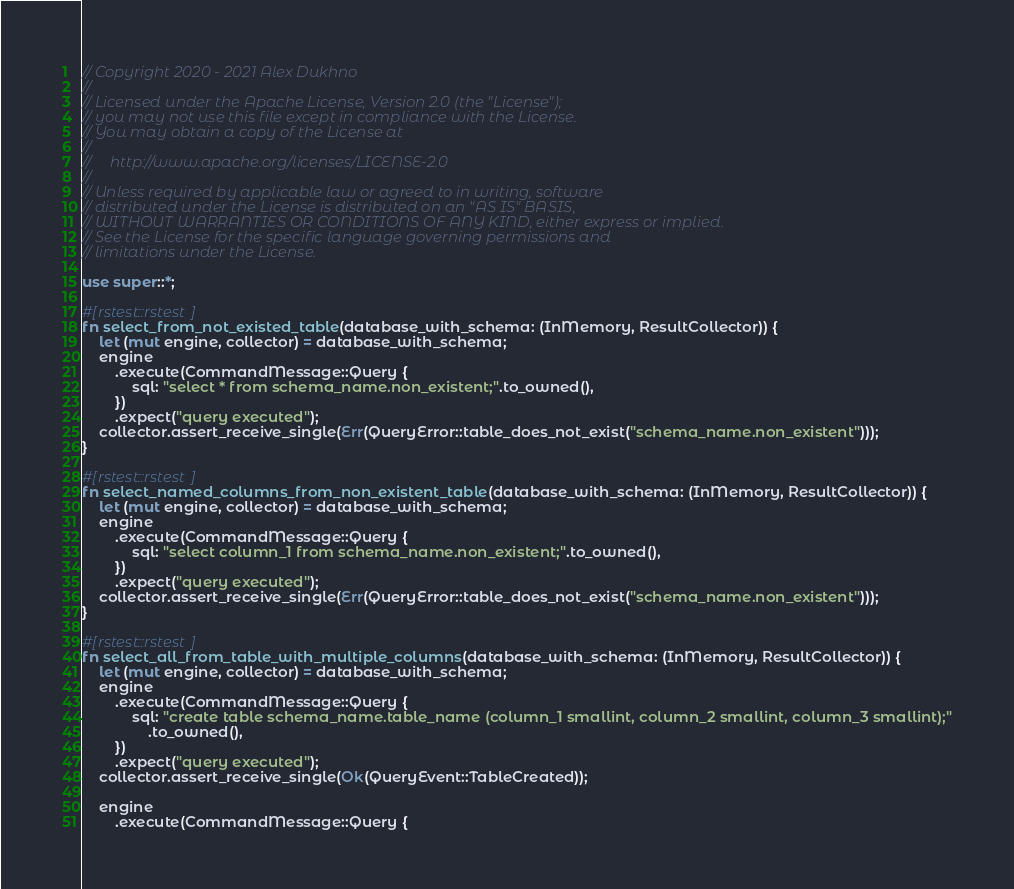<code> <loc_0><loc_0><loc_500><loc_500><_Rust_>// Copyright 2020 - 2021 Alex Dukhno
//
// Licensed under the Apache License, Version 2.0 (the "License");
// you may not use this file except in compliance with the License.
// You may obtain a copy of the License at
//
//     http://www.apache.org/licenses/LICENSE-2.0
//
// Unless required by applicable law or agreed to in writing, software
// distributed under the License is distributed on an "AS IS" BASIS,
// WITHOUT WARRANTIES OR CONDITIONS OF ANY KIND, either express or implied.
// See the License for the specific language governing permissions and
// limitations under the License.

use super::*;

#[rstest::rstest]
fn select_from_not_existed_table(database_with_schema: (InMemory, ResultCollector)) {
    let (mut engine, collector) = database_with_schema;
    engine
        .execute(CommandMessage::Query {
            sql: "select * from schema_name.non_existent;".to_owned(),
        })
        .expect("query executed");
    collector.assert_receive_single(Err(QueryError::table_does_not_exist("schema_name.non_existent")));
}

#[rstest::rstest]
fn select_named_columns_from_non_existent_table(database_with_schema: (InMemory, ResultCollector)) {
    let (mut engine, collector) = database_with_schema;
    engine
        .execute(CommandMessage::Query {
            sql: "select column_1 from schema_name.non_existent;".to_owned(),
        })
        .expect("query executed");
    collector.assert_receive_single(Err(QueryError::table_does_not_exist("schema_name.non_existent")));
}

#[rstest::rstest]
fn select_all_from_table_with_multiple_columns(database_with_schema: (InMemory, ResultCollector)) {
    let (mut engine, collector) = database_with_schema;
    engine
        .execute(CommandMessage::Query {
            sql: "create table schema_name.table_name (column_1 smallint, column_2 smallint, column_3 smallint);"
                .to_owned(),
        })
        .expect("query executed");
    collector.assert_receive_single(Ok(QueryEvent::TableCreated));

    engine
        .execute(CommandMessage::Query {</code> 